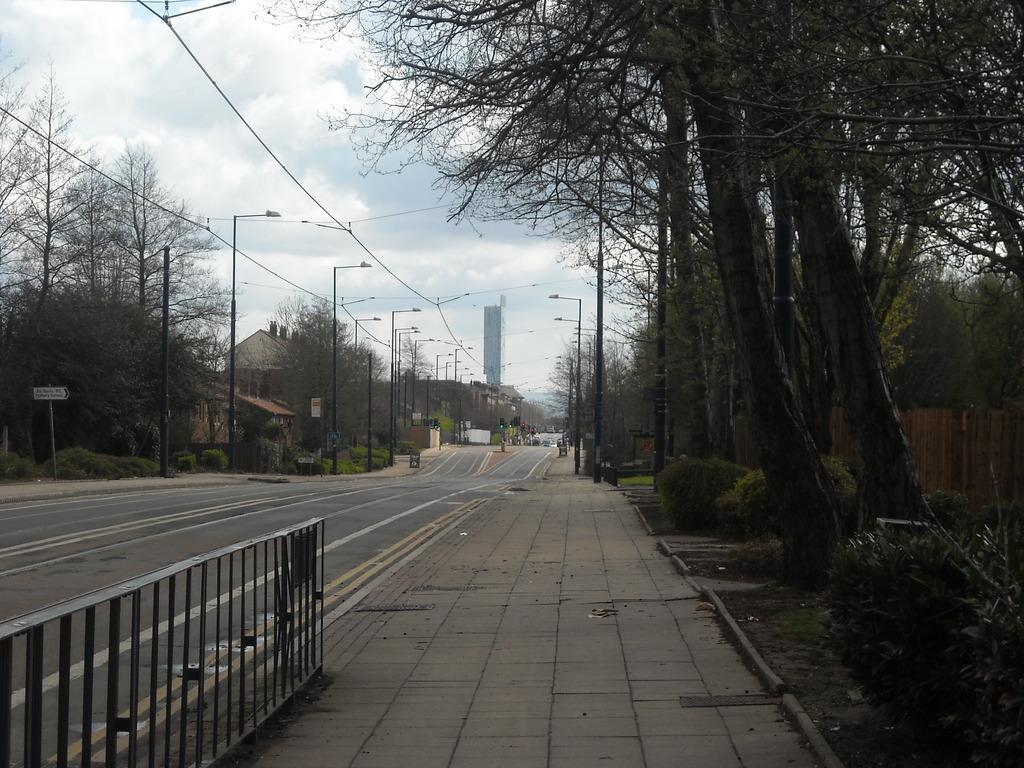How would you summarize this image in a sentence or two? As we can see in the image there are trees, buildings, street lamps and on the top there is sky. 